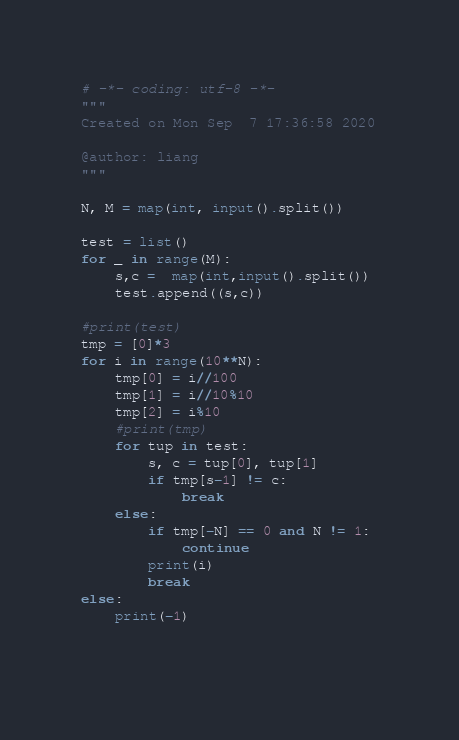<code> <loc_0><loc_0><loc_500><loc_500><_Python_># -*- coding: utf-8 -*-
"""
Created on Mon Sep  7 17:36:58 2020

@author: liang
"""

N, M = map(int, input().split())

test = list()
for _ in range(M):
    s,c =  map(int,input().split()) 
    test.append((s,c))

#print(test)
tmp = [0]*3
for i in range(10**N):
    tmp[0] = i//100
    tmp[1] = i//10%10
    tmp[2] = i%10
    #print(tmp)
    for tup in test:
        s, c = tup[0], tup[1]
        if tmp[s-1] != c:
            break
    else:
        if tmp[-N] == 0 and N != 1:
            continue
        print(i)
        break
else:
    print(-1)
        
    </code> 